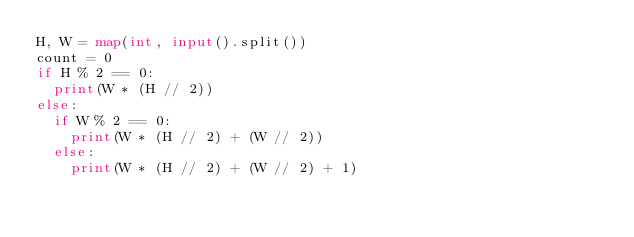<code> <loc_0><loc_0><loc_500><loc_500><_Python_>H, W = map(int, input().split())
count = 0
if H % 2 == 0:
  print(W * (H // 2))
else:
  if W % 2 == 0:
    print(W * (H // 2) + (W // 2))
  else:
    print(W * (H // 2) + (W // 2) + 1)
</code> 